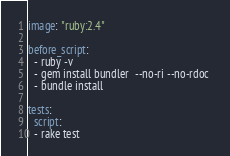Convert code to text. <code><loc_0><loc_0><loc_500><loc_500><_YAML_>image: "ruby:2.4"

before_script:
  - ruby -v
  - gem install bundler  --no-ri --no-rdoc 
  - bundle install

tests:
  script:
  - rake test
</code> 